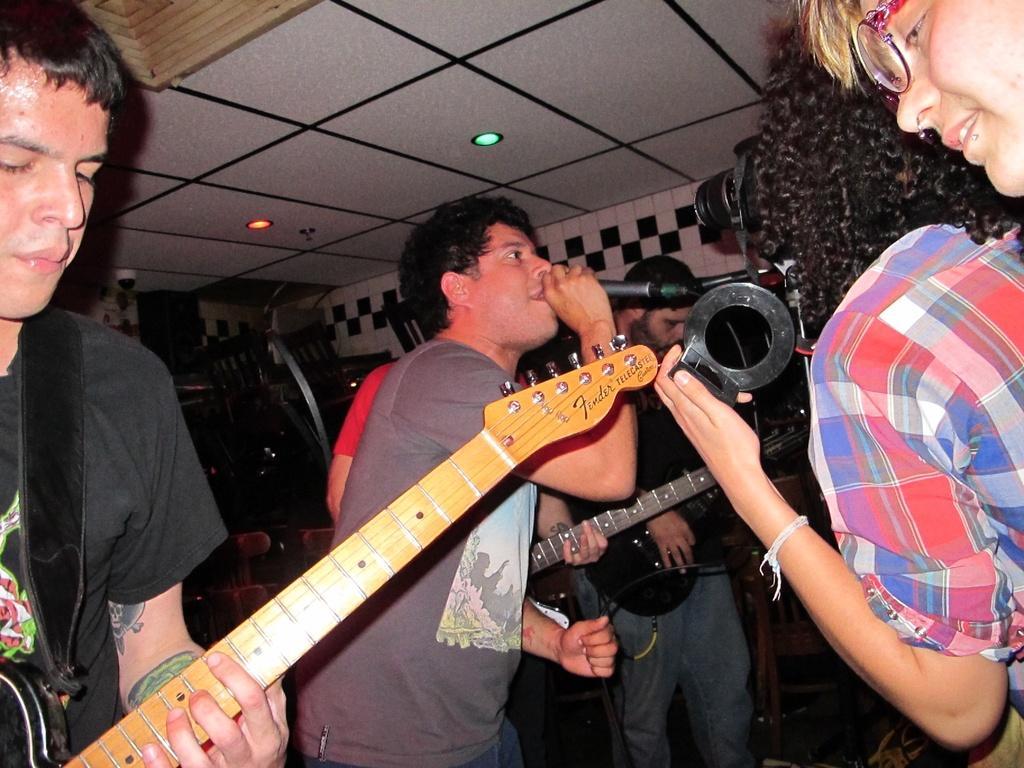In one or two sentences, can you explain what this image depicts? In this image, few peoples are there. Few are playing a musical instrument. And the middle person, holding a microphone on his hand. White color roof we can see and lights. The back side, we can see chairs. 